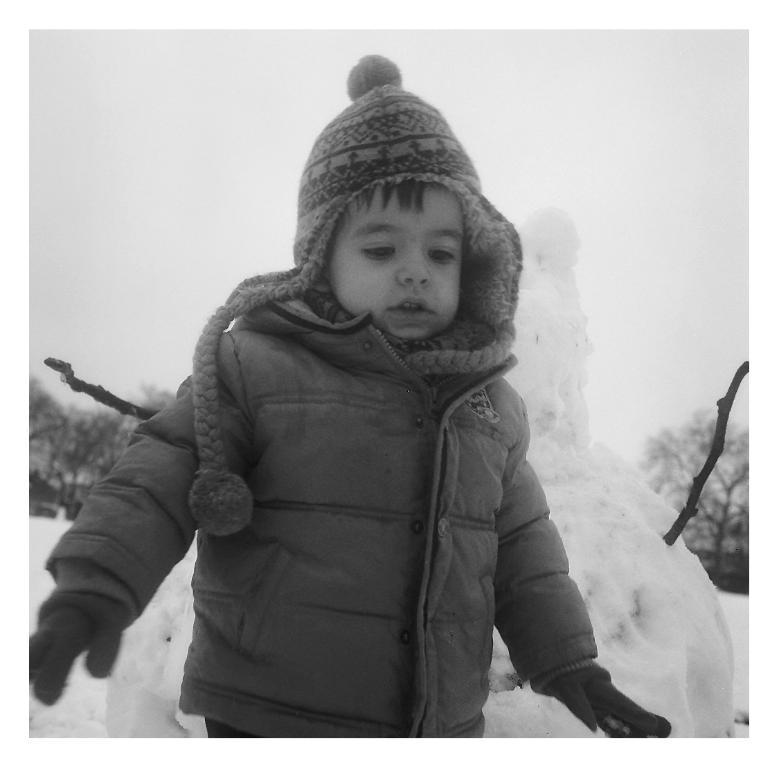How would you summarize this image in a sentence or two? In this image I can see the person with the dress. In the background I can see the snow, sticks, trees and the sky. 